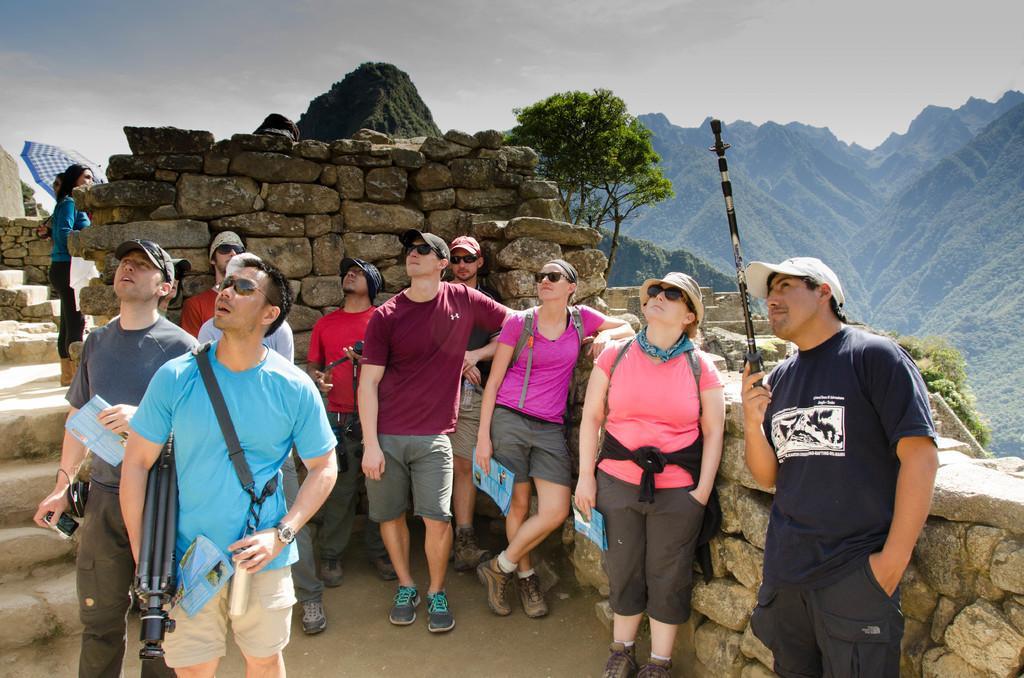Could you give a brief overview of what you see in this image? In the center of the image we can see many persons standing on the ground. In the background we can see bricks, person holding umbrella, fort, hills, sky and clouds. 